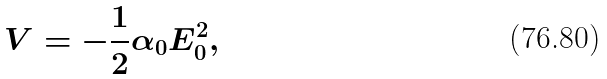Convert formula to latex. <formula><loc_0><loc_0><loc_500><loc_500>V = - \frac { 1 } { 2 } \alpha _ { 0 } E _ { 0 } ^ { 2 } ,</formula> 